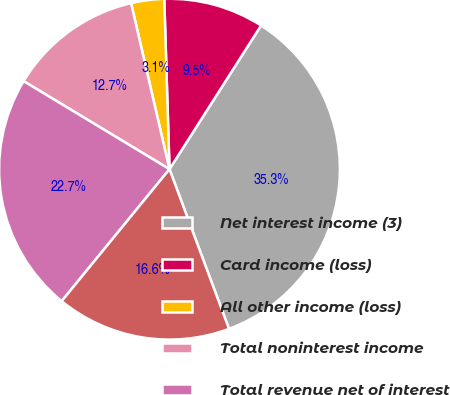Convert chart to OTSL. <chart><loc_0><loc_0><loc_500><loc_500><pie_chart><fcel>Net interest income (3)<fcel>Card income (loss)<fcel>All other income (loss)<fcel>Total noninterest income<fcel>Total revenue net of interest<fcel>Provision for credit losses<nl><fcel>35.29%<fcel>9.52%<fcel>3.13%<fcel>12.74%<fcel>22.74%<fcel>16.58%<nl></chart> 